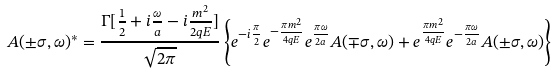Convert formula to latex. <formula><loc_0><loc_0><loc_500><loc_500>A ( \pm \sigma , \omega ) ^ { * } = \frac { \Gamma [ \frac { 1 } { 2 } + i \frac { \omega } { a } - i \frac { m ^ { 2 } } { 2 q E } ] } { \sqrt { 2 \pi } } \left \{ e ^ { - i \frac { \pi } { 2 } } e ^ { - \frac { \pi m ^ { 2 } } { 4 q E } } e ^ { \frac { \pi \omega } { 2 a } } A ( \mp \sigma , \omega ) + e ^ { \frac { \pi m ^ { 2 } } { 4 q E } } e ^ { - \frac { \pi \omega } { 2 a } } A ( \pm \sigma , \omega ) \right \}</formula> 